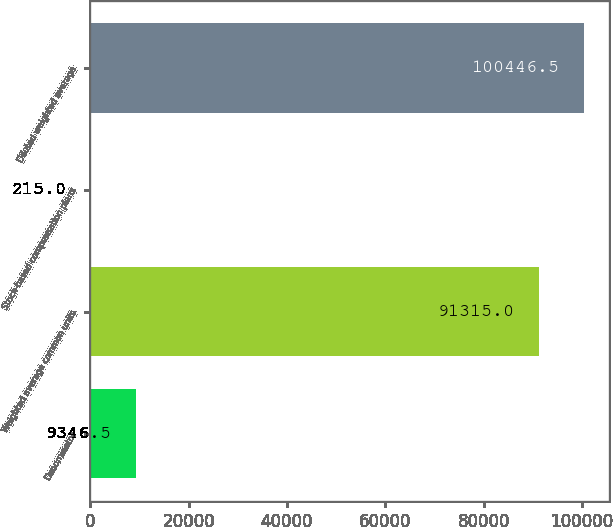<chart> <loc_0><loc_0><loc_500><loc_500><bar_chart><fcel>Denominator<fcel>Weighted average common units<fcel>Stock-based compensation plans<fcel>Diluted weighted average<nl><fcel>9346.5<fcel>91315<fcel>215<fcel>100446<nl></chart> 